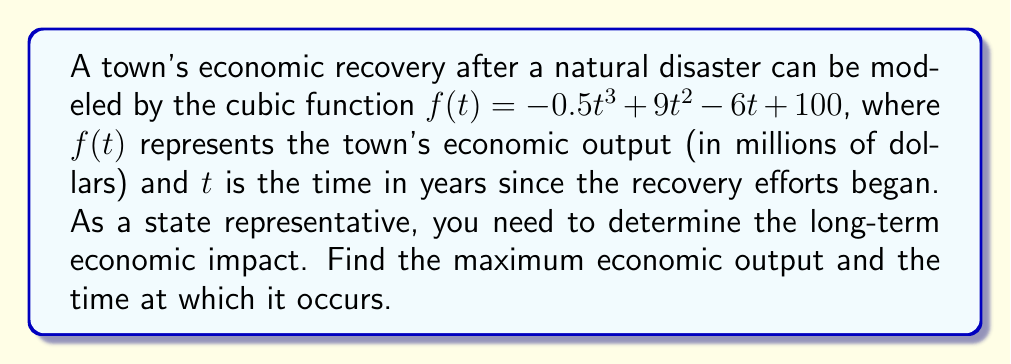Give your solution to this math problem. To find the maximum economic output and the time at which it occurs, we need to follow these steps:

1) The maximum of a cubic function occurs at one of its critical points. To find the critical points, we need to find where the derivative of $f(t)$ equals zero.

2) Find the derivative of $f(t)$:
   $f'(t) = -1.5t^2 + 18t - 6$

3) Set $f'(t) = 0$ and solve for $t$:
   $-1.5t^2 + 18t - 6 = 0$

4) This is a quadratic equation. We can solve it using the quadratic formula:
   $t = \frac{-b \pm \sqrt{b^2 - 4ac}}{2a}$

   Where $a = -1.5$, $b = 18$, and $c = -6$

5) Plugging in these values:
   $t = \frac{-18 \pm \sqrt{18^2 - 4(-1.5)(-6)}}{2(-1.5)}$
   $= \frac{-18 \pm \sqrt{324 - 36}}{-3}$
   $= \frac{-18 \pm \sqrt{288}}{-3}$
   $= \frac{-18 \pm 12\sqrt{2}}{-3}$

6) This gives us two critical points:
   $t_1 = \frac{-18 + 12\sqrt{2}}{-3} = 6 - 2\sqrt{2}$
   $t_2 = \frac{-18 - 12\sqrt{2}}{-3} = 6 + 2\sqrt{2}$

7) To determine which of these gives the maximum, we can check the second derivative:
   $f''(t) = -3t + 18$
   At $t = 6 - 2\sqrt{2}$, $f''(t) < 0$, indicating a local maximum.
   At $t = 6 + 2\sqrt{2}$, $f''(t) > 0$, indicating a local minimum.

8) Therefore, the maximum occurs at $t = 6 - 2\sqrt{2} \approx 3.17$ years.

9) To find the maximum economic output, we plug this value back into our original function:
   $f(6 - 2\sqrt{2}) = -0.5(6 - 2\sqrt{2})^3 + 9(6 - 2\sqrt{2})^2 - 6(6 - 2\sqrt{2}) + 100$

10) Simplifying this expression (which involves some complex algebra) gives us the maximum value.
Answer: The maximum economic output occurs approximately 3.17 years after recovery efforts begin, and the maximum output is approximately $154.51$ million dollars. 